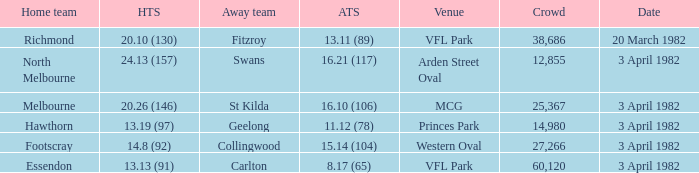When the away team scored 11.12 (78), what was the date of the game? 3 April 1982. 